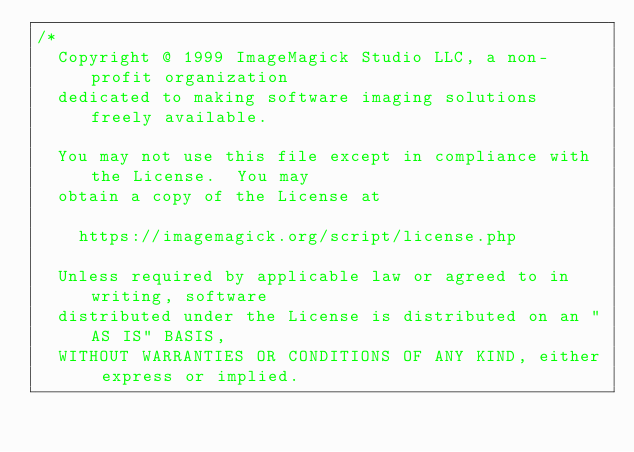Convert code to text. <code><loc_0><loc_0><loc_500><loc_500><_C_>/*
  Copyright @ 1999 ImageMagick Studio LLC, a non-profit organization
  dedicated to making software imaging solutions freely available.

  You may not use this file except in compliance with the License.  You may
  obtain a copy of the License at

    https://imagemagick.org/script/license.php

  Unless required by applicable law or agreed to in writing, software
  distributed under the License is distributed on an "AS IS" BASIS,
  WITHOUT WARRANTIES OR CONDITIONS OF ANY KIND, either express or implied.</code> 